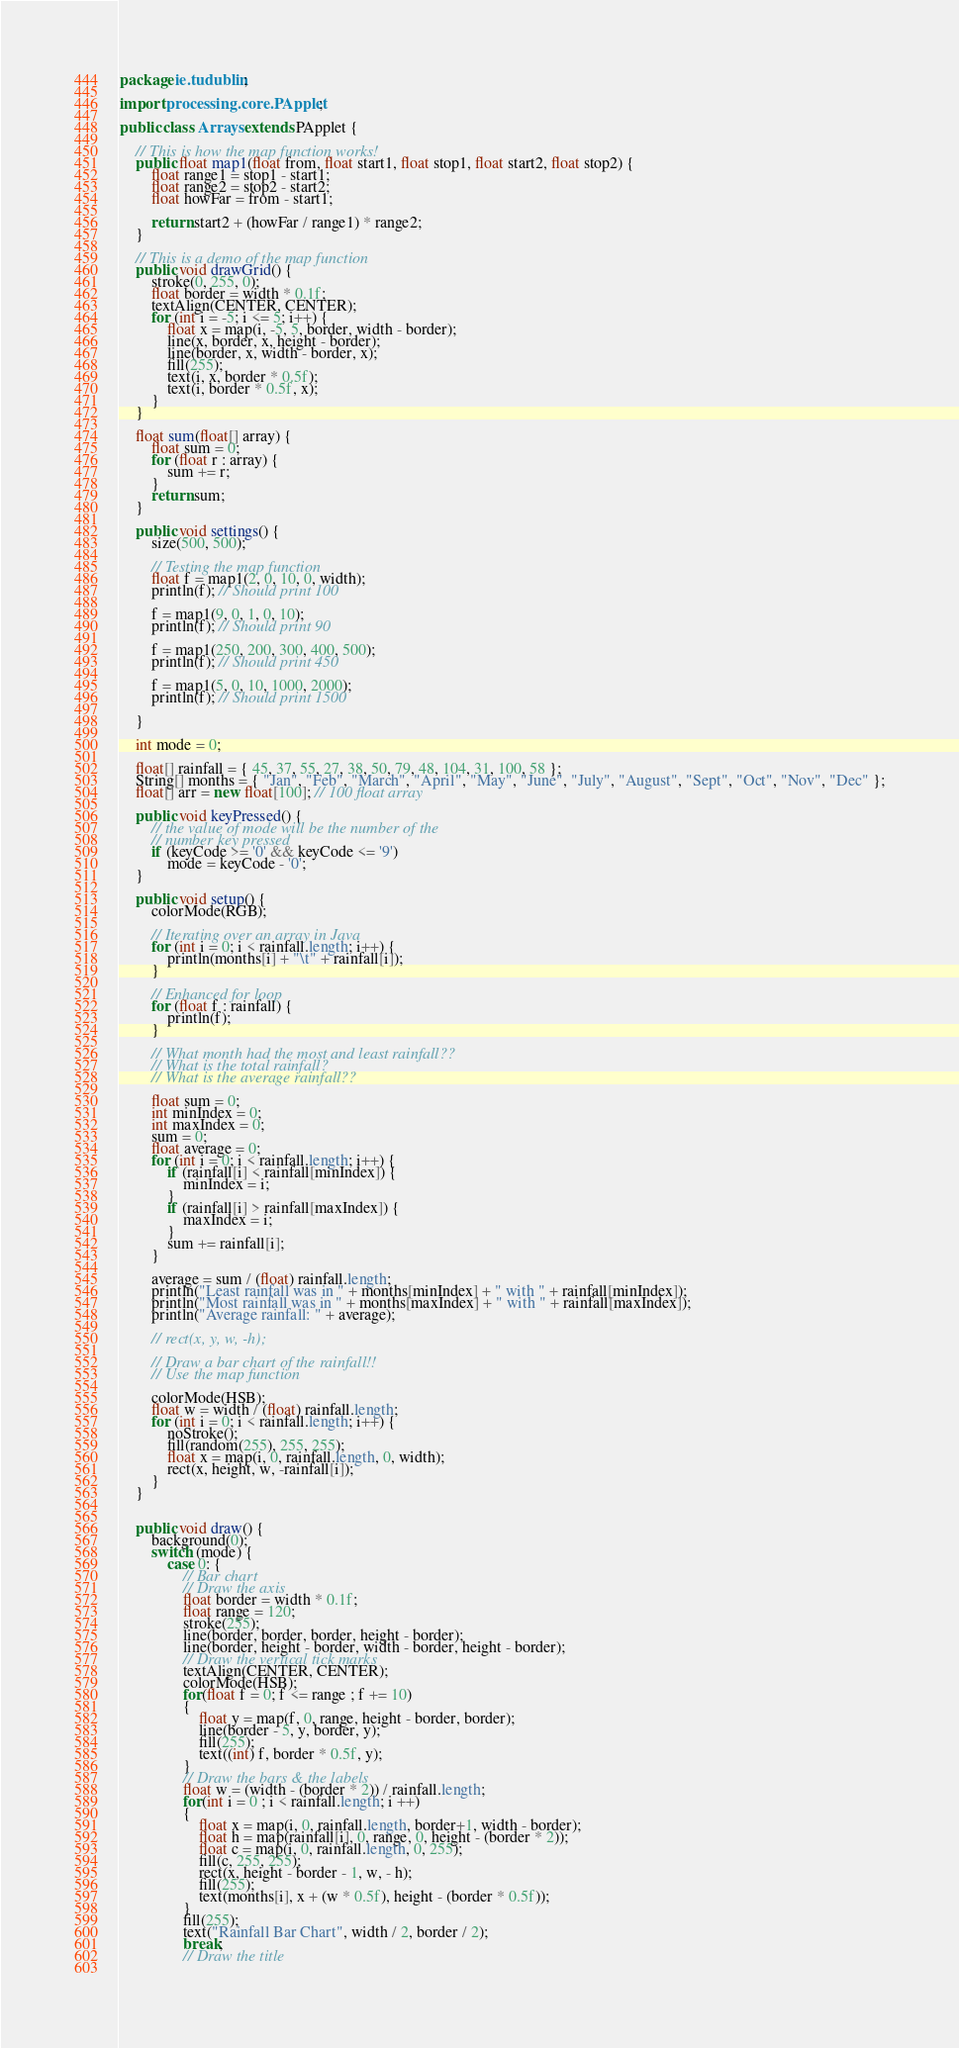Convert code to text. <code><loc_0><loc_0><loc_500><loc_500><_Java_>package ie.tudublin;

import processing.core.PApplet;

public class Arrays extends PApplet {

    // This is how the map function works!
    public float map1(float from, float start1, float stop1, float start2, float stop2) {
        float range1 = stop1 - start1;
        float range2 = stop2 - start2;
        float howFar = from - start1;

        return start2 + (howFar / range1) * range2;
    }

    // This is a demo of the map function
    public void drawGrid() {
        stroke(0, 255, 0);
        float border = width * 0.1f;
        textAlign(CENTER, CENTER);
        for (int i = -5; i <= 5; i++) {
            float x = map(i, -5, 5, border, width - border);
            line(x, border, x, height - border);
            line(border, x, width - border, x);
            fill(255);
            text(i, x, border * 0.5f);
            text(i, border * 0.5f, x);
        }
    }
    
    float sum(float[] array) {
        float sum = 0;
        for (float r : array) {
            sum += r;
        }
        return sum;
    }

    public void settings() {
        size(500, 500);

        // Testing the map function
        float f = map1(2, 0, 10, 0, width);
        println(f); // Should print 100

        f = map1(9, 0, 1, 0, 10);
        println(f); // Should print 90

        f = map1(250, 200, 300, 400, 500);
        println(f); // Should print 450

        f = map1(5, 0, 10, 1000, 2000);
        println(f); // Should print 1500

    }

    int mode = 0;

    float[] rainfall = { 45, 37, 55, 27, 38, 50, 79, 48, 104, 31, 100, 58 };
    String[] months = { "Jan", "Feb", "March", "April", "May", "June", "July", "August", "Sept", "Oct", "Nov", "Dec" };
    float[] arr = new float[100]; // 100 float array

    public void keyPressed() {
        // the value of mode will be the number of the
        // number key pressed
        if (keyCode >= '0' && keyCode <= '9')
            mode = keyCode - '0';
    }

    public void setup() {
        colorMode(RGB);

        // Iterating over an array in Java
        for (int i = 0; i < rainfall.length; i++) {
            println(months[i] + "\t" + rainfall[i]);
        }

        // Enhanced for loop
        for (float f : rainfall) {
            println(f);
        }

        // What month had the most and least rainfall??
        // What is the total rainfall?
        // What is the average rainfall??

        float sum = 0;
        int minIndex = 0;
        int maxIndex = 0;
        sum = 0;
        float average = 0;
        for (int i = 0; i < rainfall.length; i++) {
            if (rainfall[i] < rainfall[minIndex]) {
                minIndex = i;
            }
            if (rainfall[i] > rainfall[maxIndex]) {
                maxIndex = i;
            }
            sum += rainfall[i];
        }

        average = sum / (float) rainfall.length;
        println("Least rainfall was in " + months[minIndex] + " with " + rainfall[minIndex]);
        println("Most rainfall was in " + months[maxIndex] + " with " + rainfall[maxIndex]);
        println("Average rainfall: " + average);

        // rect(x, y, w, -h);

        // Draw a bar chart of the rainfall!!
        // Use the map function

        colorMode(HSB);
        float w = width / (float) rainfall.length;
        for (int i = 0; i < rainfall.length; i++) {
            noStroke();
            fill(random(255), 255, 255);
            float x = map(i, 0, rainfall.length, 0, width);
            rect(x, height, w, -rainfall[i]);
        }
    }


    public void draw() {
        background(0);
        switch (mode) {
            case 0: {
                // Bar chart
                // Draw the axis
                float border = width * 0.1f;
                float range = 120;
                stroke(255);
                line(border, border, border, height - border);
                line(border, height - border, width - border, height - border);
                // Draw the vertical tick marks
                textAlign(CENTER, CENTER);
                colorMode(HSB);
                for(float f = 0; f <= range ; f += 10)
                {
                    float y = map(f, 0, range, height - border, border);
                    line(border - 5, y, border, y);
                    fill(255);
                    text((int) f, border * 0.5f, y);
                }    
                // Draw the bars & the labels
                float w = (width - (border * 2)) / rainfall.length;
                for(int i = 0 ; i < rainfall.length; i ++)
                {
                    float x = map(i, 0, rainfall.length, border+1, width - border);
                    float h = map(rainfall[i], 0, range, 0, height - (border * 2));
                    float c = map(i, 0, rainfall.length, 0, 255);
                    fill(c, 255, 255);
                    rect(x, height - border - 1, w, - h);
                    fill(255);
                    text(months[i], x + (w * 0.5f), height - (border * 0.5f));
                }
                fill(255);
                text("Rainfall Bar Chart", width / 2, border / 2);
                break;
                // Draw the title
                </code> 